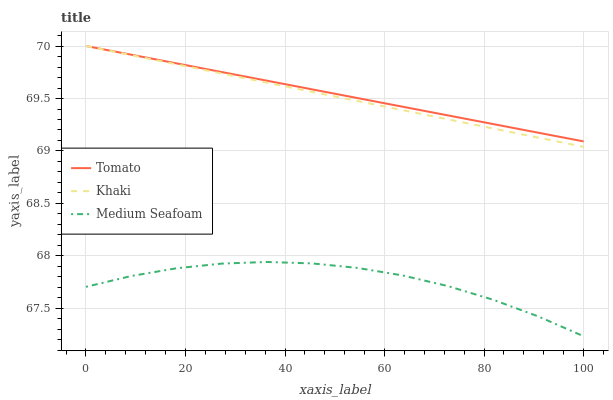Does Medium Seafoam have the minimum area under the curve?
Answer yes or no. Yes. Does Tomato have the maximum area under the curve?
Answer yes or no. Yes. Does Khaki have the minimum area under the curve?
Answer yes or no. No. Does Khaki have the maximum area under the curve?
Answer yes or no. No. Is Khaki the smoothest?
Answer yes or no. Yes. Is Medium Seafoam the roughest?
Answer yes or no. Yes. Is Medium Seafoam the smoothest?
Answer yes or no. No. Is Khaki the roughest?
Answer yes or no. No. Does Medium Seafoam have the lowest value?
Answer yes or no. Yes. Does Khaki have the lowest value?
Answer yes or no. No. Does Khaki have the highest value?
Answer yes or no. Yes. Does Medium Seafoam have the highest value?
Answer yes or no. No. Is Medium Seafoam less than Khaki?
Answer yes or no. Yes. Is Tomato greater than Medium Seafoam?
Answer yes or no. Yes. Does Khaki intersect Tomato?
Answer yes or no. Yes. Is Khaki less than Tomato?
Answer yes or no. No. Is Khaki greater than Tomato?
Answer yes or no. No. Does Medium Seafoam intersect Khaki?
Answer yes or no. No. 